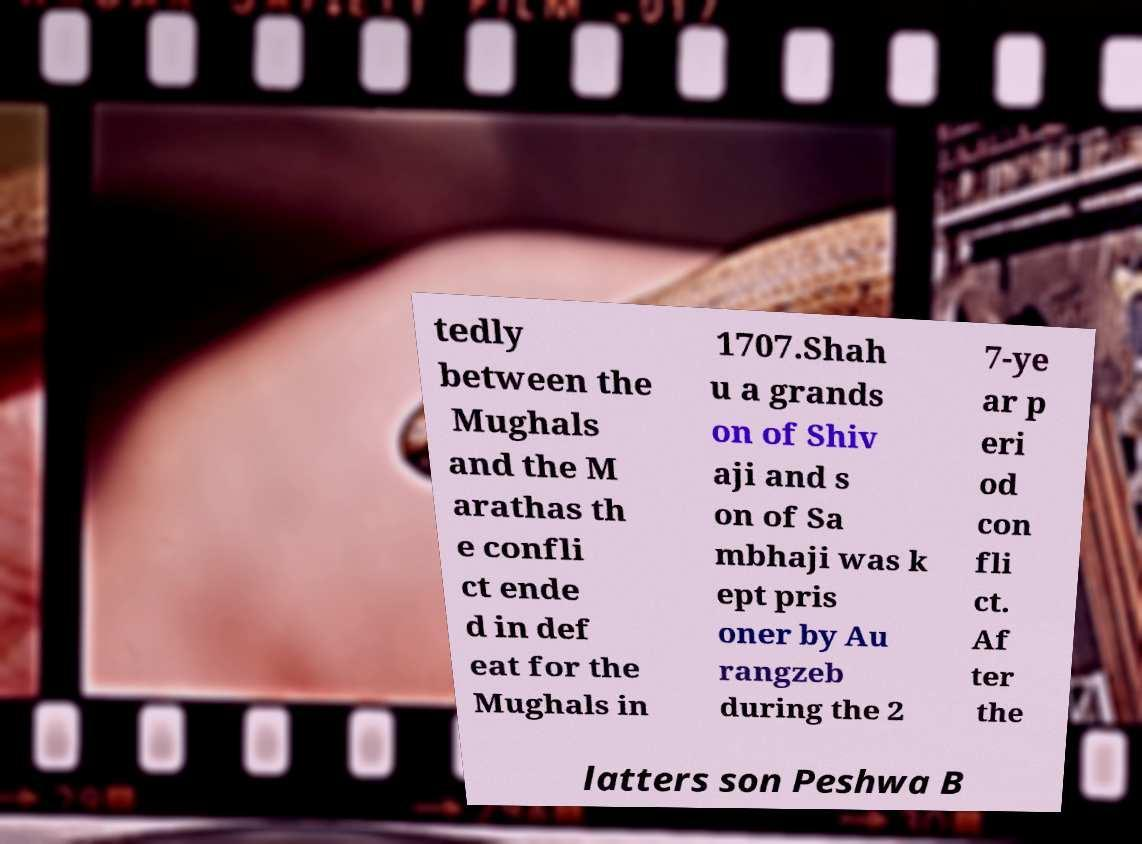What messages or text are displayed in this image? I need them in a readable, typed format. tedly between the Mughals and the M arathas th e confli ct ende d in def eat for the Mughals in 1707.Shah u a grands on of Shiv aji and s on of Sa mbhaji was k ept pris oner by Au rangzeb during the 2 7-ye ar p eri od con fli ct. Af ter the latters son Peshwa B 